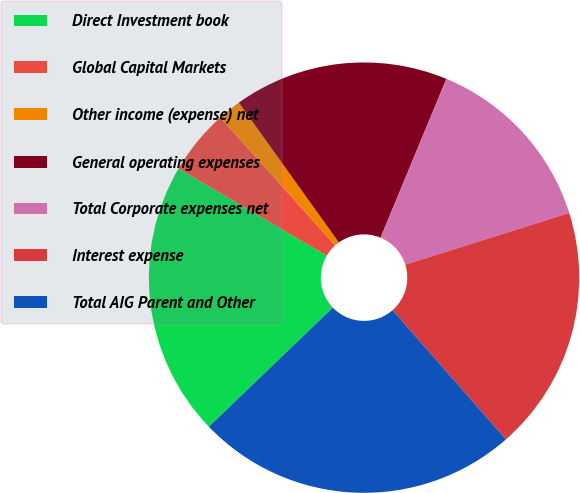Convert chart. <chart><loc_0><loc_0><loc_500><loc_500><pie_chart><fcel>Direct Investment book<fcel>Global Capital Markets<fcel>Other income (expense) net<fcel>General operating expenses<fcel>Total Corporate expenses net<fcel>Interest expense<fcel>Total AIG Parent and Other<nl><fcel>20.65%<fcel>4.9%<fcel>1.75%<fcel>16.14%<fcel>13.89%<fcel>18.4%<fcel>24.28%<nl></chart> 